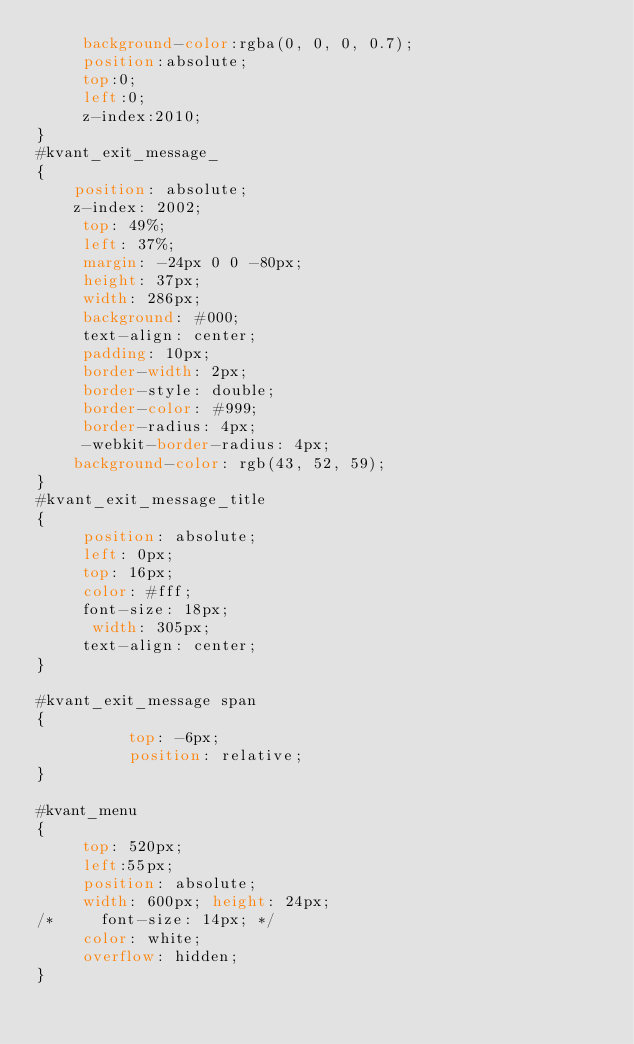Convert code to text. <code><loc_0><loc_0><loc_500><loc_500><_CSS_>     background-color:rgba(0, 0, 0, 0.7);
     position:absolute;
     top:0;
     left:0;
     z-index:2010;
}
#kvant_exit_message_
{
    position: absolute;
    z-index: 2002;
     top: 49%;
     left: 37%;
     margin: -24px 0 0 -80px;
     height: 37px;
     width: 286px;
     background: #000;
     text-align: center;
     padding: 10px;
     border-width: 2px;
     border-style: double;
     border-color: #999;
     border-radius: 4px;
     -webkit-border-radius: 4px;
	background-color: rgb(43, 52, 59);
}
#kvant_exit_message_title
{
     position: absolute;
     left: 0px;
     top: 16px;
     color: #fff;
     font-size: 18px;
      width: 305px;
     text-align: center;
}

#kvant_exit_message span
{
          top: -6px;
          position: relative;
}

#kvant_menu
{
     top: 520px;
     left:55px;
     position: absolute;
     width: 600px; height: 24px;
/*     font-size: 14px; */
     color: white;
     overflow: hidden;
}
</code> 